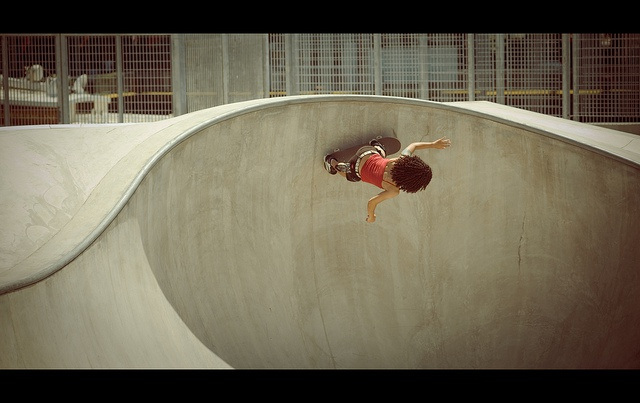Describe the objects in this image and their specific colors. I can see people in black, maroon, brown, and gray tones and skateboard in black, maroon, gray, and tan tones in this image. 